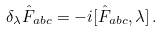<formula> <loc_0><loc_0><loc_500><loc_500>\delta _ { \lambda } \hat { F } _ { a b c } = - i [ \hat { F } _ { a b c } , \lambda ] \, .</formula> 